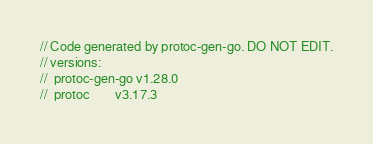<code> <loc_0><loc_0><loc_500><loc_500><_Go_>// Code generated by protoc-gen-go. DO NOT EDIT.
// versions:
// 	protoc-gen-go v1.28.0
// 	protoc        v3.17.3</code> 